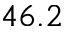<formula> <loc_0><loc_0><loc_500><loc_500>4 6 . 2</formula> 